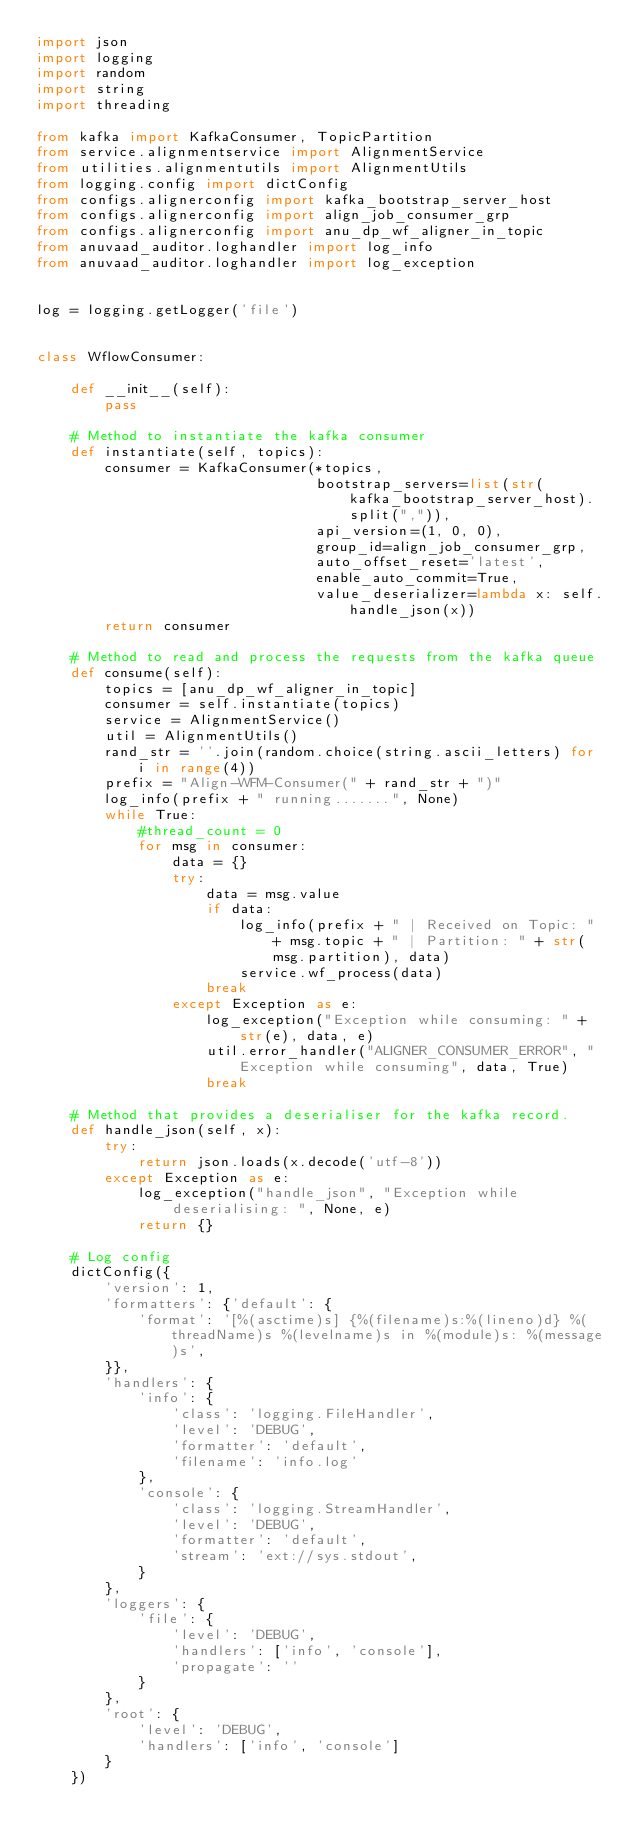<code> <loc_0><loc_0><loc_500><loc_500><_Python_>import json
import logging
import random
import string
import threading

from kafka import KafkaConsumer, TopicPartition
from service.alignmentservice import AlignmentService
from utilities.alignmentutils import AlignmentUtils
from logging.config import dictConfig
from configs.alignerconfig import kafka_bootstrap_server_host
from configs.alignerconfig import align_job_consumer_grp
from configs.alignerconfig import anu_dp_wf_aligner_in_topic
from anuvaad_auditor.loghandler import log_info
from anuvaad_auditor.loghandler import log_exception


log = logging.getLogger('file')


class WflowConsumer:

    def __init__(self):
        pass

    # Method to instantiate the kafka consumer
    def instantiate(self, topics):
        consumer = KafkaConsumer(*topics,
                                 bootstrap_servers=list(str(kafka_bootstrap_server_host).split(",")),
                                 api_version=(1, 0, 0),
                                 group_id=align_job_consumer_grp,
                                 auto_offset_reset='latest',
                                 enable_auto_commit=True,
                                 value_deserializer=lambda x: self.handle_json(x))
        return consumer

    # Method to read and process the requests from the kafka queue
    def consume(self):
        topics = [anu_dp_wf_aligner_in_topic]
        consumer = self.instantiate(topics)
        service = AlignmentService()
        util = AlignmentUtils()
        rand_str = ''.join(random.choice(string.ascii_letters) for i in range(4))
        prefix = "Align-WFM-Consumer(" + rand_str + ")"
        log_info(prefix + " running.......", None)
        while True:
            #thread_count = 0
            for msg in consumer:
                data = {}
                try:
                    data = msg.value
                    if data:
                        log_info(prefix + " | Received on Topic: " + msg.topic + " | Partition: " + str(msg.partition), data)
                        service.wf_process(data)
                    break
                except Exception as e:
                    log_exception("Exception while consuming: " + str(e), data, e)
                    util.error_handler("ALIGNER_CONSUMER_ERROR", "Exception while consuming", data, True)
                    break

    # Method that provides a deserialiser for the kafka record.
    def handle_json(self, x):
        try:
            return json.loads(x.decode('utf-8'))
        except Exception as e:
            log_exception("handle_json", "Exception while deserialising: ", None, e)
            return {}

    # Log config
    dictConfig({
        'version': 1,
        'formatters': {'default': {
            'format': '[%(asctime)s] {%(filename)s:%(lineno)d} %(threadName)s %(levelname)s in %(module)s: %(message)s',
        }},
        'handlers': {
            'info': {
                'class': 'logging.FileHandler',
                'level': 'DEBUG',
                'formatter': 'default',
                'filename': 'info.log'
            },
            'console': {
                'class': 'logging.StreamHandler',
                'level': 'DEBUG',
                'formatter': 'default',
                'stream': 'ext://sys.stdout',
            }
        },
        'loggers': {
            'file': {
                'level': 'DEBUG',
                'handlers': ['info', 'console'],
                'propagate': ''
            }
        },
        'root': {
            'level': 'DEBUG',
            'handlers': ['info', 'console']
        }
    })
</code> 